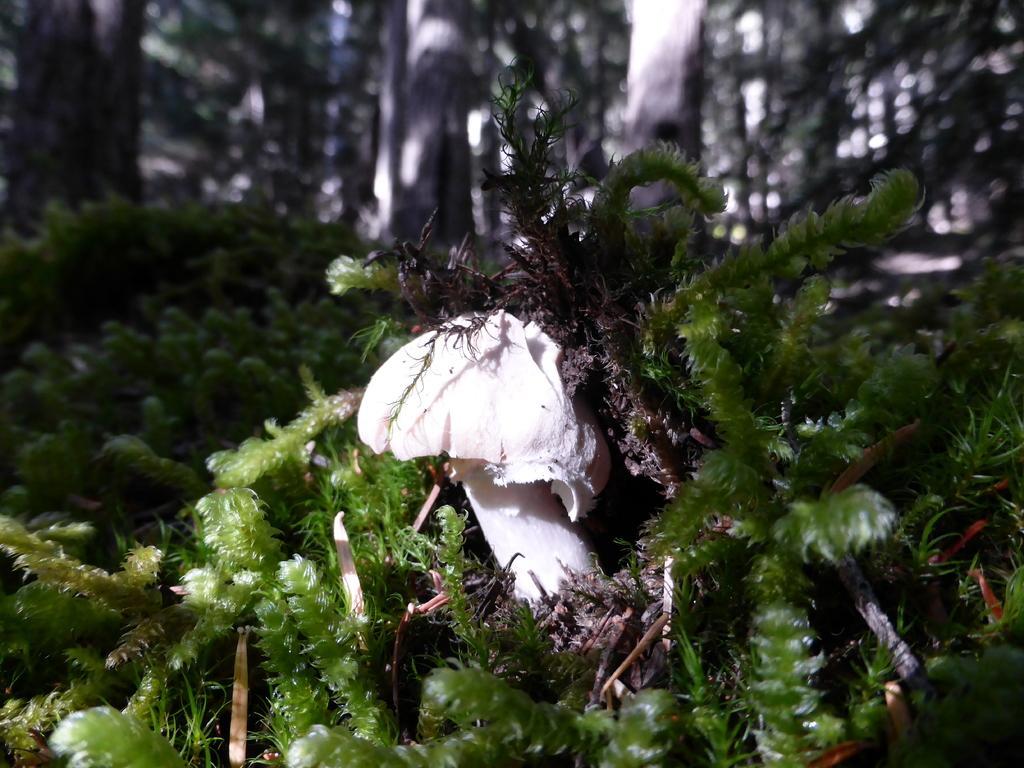How would you summarize this image in a sentence or two? In the middle of the image we can see a mushroom, and we can find few plants and trees. 